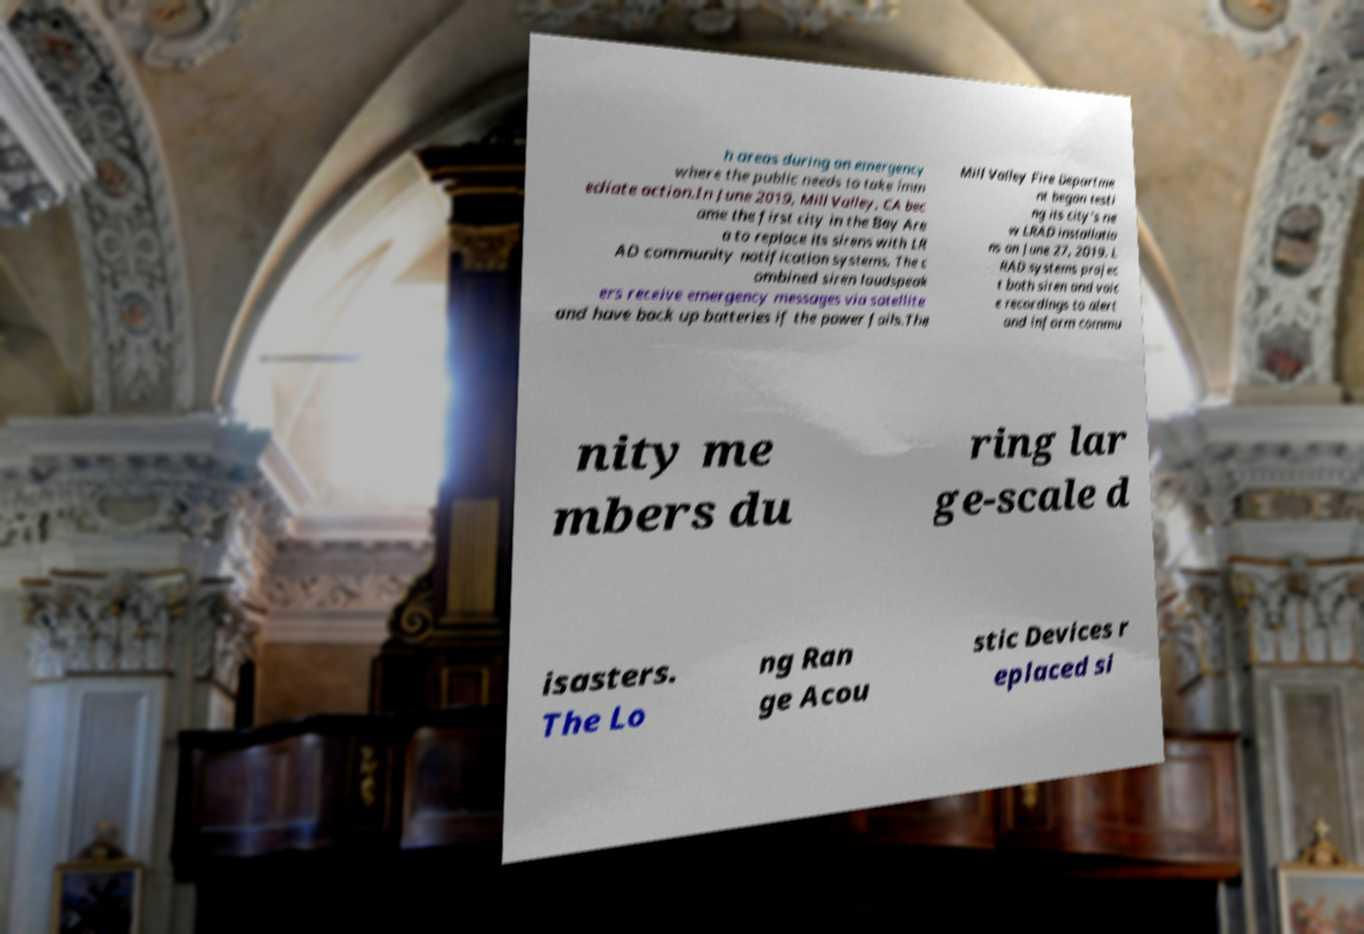I need the written content from this picture converted into text. Can you do that? h areas during an emergency where the public needs to take imm ediate action.In June 2019, Mill Valley, CA bec ame the first city in the Bay Are a to replace its sirens with LR AD community notification systems. The c ombined siren loudspeak ers receive emergency messages via satellite and have back up batteries if the power fails.The Mill Valley Fire Departme nt began testi ng its city's ne w LRAD installatio ns on June 27, 2019. L RAD systems projec t both siren and voic e recordings to alert and inform commu nity me mbers du ring lar ge-scale d isasters. The Lo ng Ran ge Acou stic Devices r eplaced si 